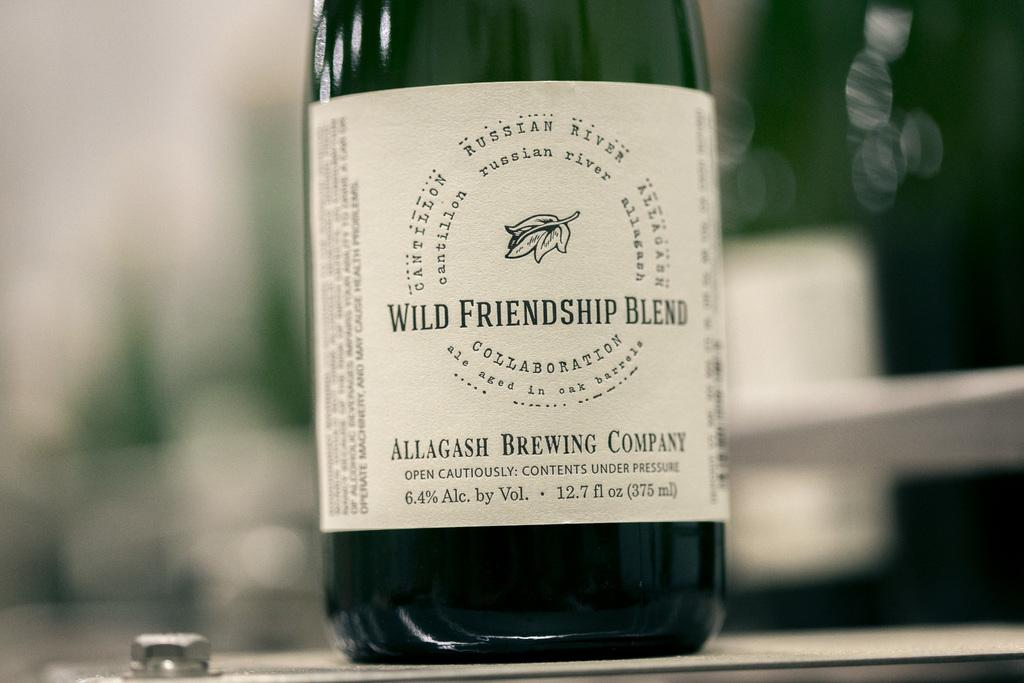<image>
Offer a succinct explanation of the picture presented. the name wild that is on a wine bottle 